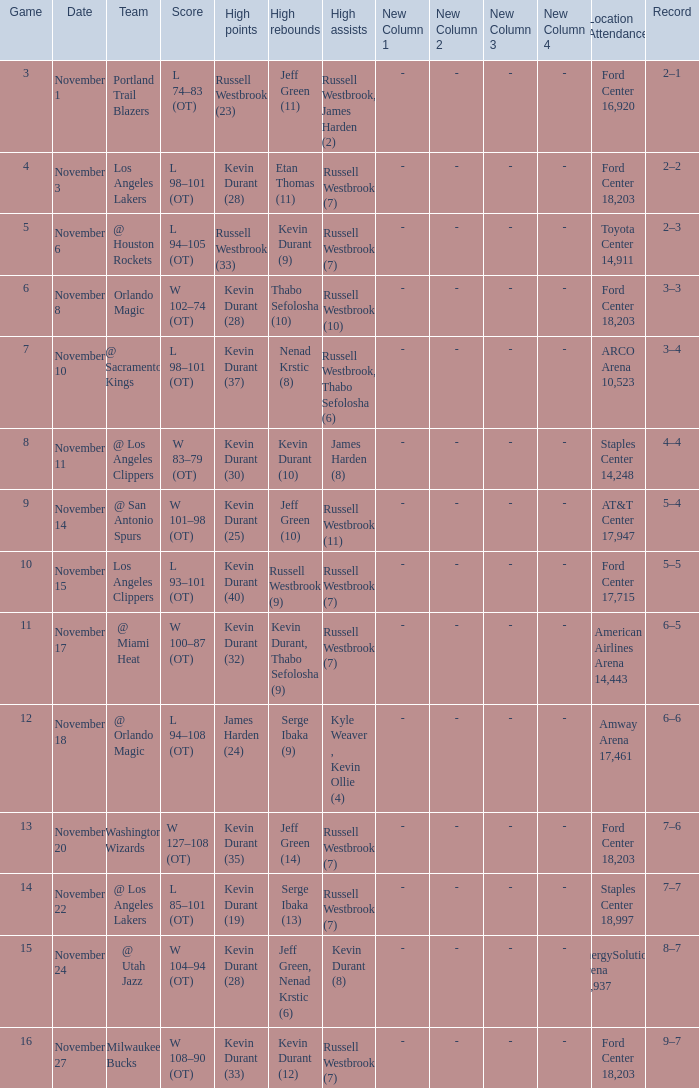Can you parse all the data within this table? {'header': ['Game', 'Date', 'Team', 'Score', 'High points', 'High rebounds', 'High assists', 'New Column 1', 'New Column 2', 'New Column 3', 'New Column 4', 'Location Attendance', 'Record'], 'rows': [['3', 'November 1', 'Portland Trail Blazers', 'L 74–83 (OT)', 'Russell Westbrook (23)', 'Jeff Green (11)', 'Russell Westbrook, James Harden (2)', '-', '-', '-', '-', 'Ford Center 16,920', '2–1'], ['4', 'November 3', 'Los Angeles Lakers', 'L 98–101 (OT)', 'Kevin Durant (28)', 'Etan Thomas (11)', 'Russell Westbrook (7)', '-', '-', '-', '-', 'Ford Center 18,203', '2–2'], ['5', 'November 6', '@ Houston Rockets', 'L 94–105 (OT)', 'Russell Westbrook (33)', 'Kevin Durant (9)', 'Russell Westbrook (7)', '-', '-', '-', '-', 'Toyota Center 14,911', '2–3'], ['6', 'November 8', 'Orlando Magic', 'W 102–74 (OT)', 'Kevin Durant (28)', 'Thabo Sefolosha (10)', 'Russell Westbrook (10)', '-', '-', '-', '-', 'Ford Center 18,203', '3–3'], ['7', 'November 10', '@ Sacramento Kings', 'L 98–101 (OT)', 'Kevin Durant (37)', 'Nenad Krstic (8)', 'Russell Westbrook, Thabo Sefolosha (6)', '-', '-', '-', '-', 'ARCO Arena 10,523', '3–4'], ['8', 'November 11', '@ Los Angeles Clippers', 'W 83–79 (OT)', 'Kevin Durant (30)', 'Kevin Durant (10)', 'James Harden (8)', '-', '-', '-', '-', 'Staples Center 14,248', '4–4'], ['9', 'November 14', '@ San Antonio Spurs', 'W 101–98 (OT)', 'Kevin Durant (25)', 'Jeff Green (10)', 'Russell Westbrook (11)', '-', '-', '-', '-', 'AT&T Center 17,947', '5–4'], ['10', 'November 15', 'Los Angeles Clippers', 'L 93–101 (OT)', 'Kevin Durant (40)', 'Russell Westbrook (9)', 'Russell Westbrook (7)', '-', '-', '-', '-', 'Ford Center 17,715', '5–5'], ['11', 'November 17', '@ Miami Heat', 'W 100–87 (OT)', 'Kevin Durant (32)', 'Kevin Durant, Thabo Sefolosha (9)', 'Russell Westbrook (7)', '-', '-', '-', '-', 'American Airlines Arena 14,443', '6–5'], ['12', 'November 18', '@ Orlando Magic', 'L 94–108 (OT)', 'James Harden (24)', 'Serge Ibaka (9)', 'Kyle Weaver , Kevin Ollie (4)', '-', '-', '-', '-', 'Amway Arena 17,461', '6–6'], ['13', 'November 20', 'Washington Wizards', 'W 127–108 (OT)', 'Kevin Durant (35)', 'Jeff Green (14)', 'Russell Westbrook (7)', '-', '-', '-', '-', 'Ford Center 18,203', '7–6'], ['14', 'November 22', '@ Los Angeles Lakers', 'L 85–101 (OT)', 'Kevin Durant (19)', 'Serge Ibaka (13)', 'Russell Westbrook (7)', '-', '-', '-', '-', 'Staples Center 18,997', '7–7'], ['15', 'November 24', '@ Utah Jazz', 'W 104–94 (OT)', 'Kevin Durant (28)', 'Jeff Green, Nenad Krstic (6)', 'Kevin Durant (8)', '-', '-', '-', '-', 'EnergySolutions Arena 17,937', '8–7'], ['16', 'November 27', 'Milwaukee Bucks', 'W 108–90 (OT)', 'Kevin Durant (33)', 'Kevin Durant (12)', 'Russell Westbrook (7)', '-', '-', '-', '-', 'Ford Center 18,203', '9–7']]} What was the record in the game in which Jeff Green (14) did the most high rebounds? 7–6. 